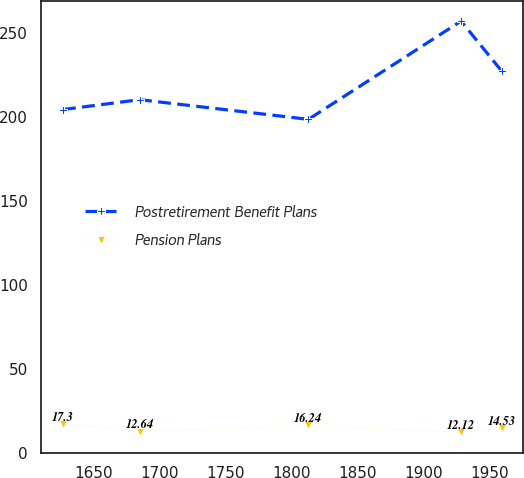<chart> <loc_0><loc_0><loc_500><loc_500><line_chart><ecel><fcel>Postretirement Benefit Plans<fcel>Pension Plans<nl><fcel>1626.64<fcel>204.58<fcel>17.3<nl><fcel>1684.81<fcel>210.44<fcel>12.64<nl><fcel>1812.82<fcel>198.72<fcel>16.24<nl><fcel>1928.64<fcel>257.28<fcel>12.12<nl><fcel>1959.33<fcel>227.62<fcel>14.53<nl></chart> 